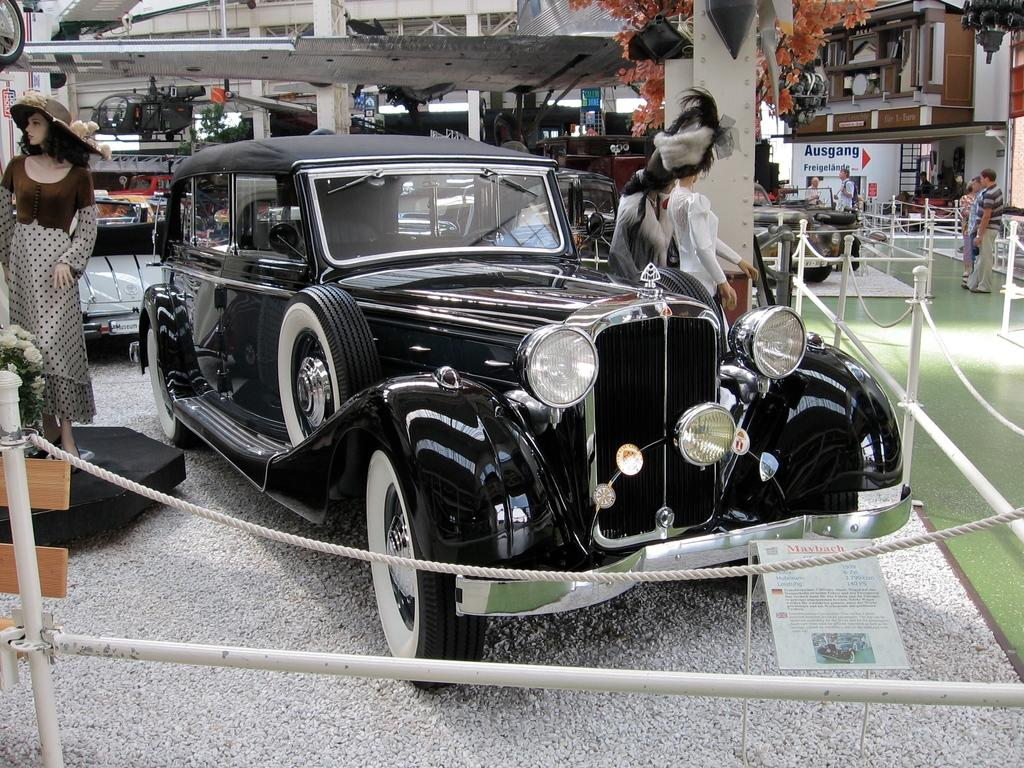What types of objects are present in the image? There are vehicles and persons on the ground in the image. Can you describe any structures or barriers in the image? Yes, there is a fence in the image. What can be seen in the background of the image? There are pillars and house plants in the background of the image. What color is the brain that is visible in the image? There is no brain present in the image. What type of paint is being used by the women in the image? There are no women or paint present in the image. 